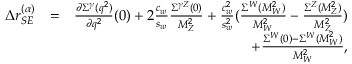<formula> <loc_0><loc_0><loc_500><loc_500>\begin{array} { r l r } { \Delta r _ { S E } ^ { ( \alpha ) } } & { = } & { \frac { \partial \Sigma ^ { \gamma } ( q ^ { 2 } ) } { \partial q ^ { 2 } } ( 0 ) + 2 \frac { c _ { w } } { s _ { w } } \frac { \Sigma ^ { \gamma Z } ( 0 ) } { M _ { Z } ^ { 2 } } + \frac { c _ { w } ^ { 2 } } { s _ { w } ^ { 2 } } ( \frac { \Sigma ^ { W } ( M _ { W } ^ { 2 } ) } { M _ { W } ^ { 2 } } - \frac { \Sigma ^ { Z } ( M _ { Z } ^ { 2 } ) } { M _ { Z } ^ { 2 } } ) } \\ & { + \frac { \Sigma ^ { W } ( 0 ) - \Sigma ^ { W } ( M _ { W } ^ { 2 } ) } { M _ { W } ^ { 2 } } , } \end{array}</formula> 